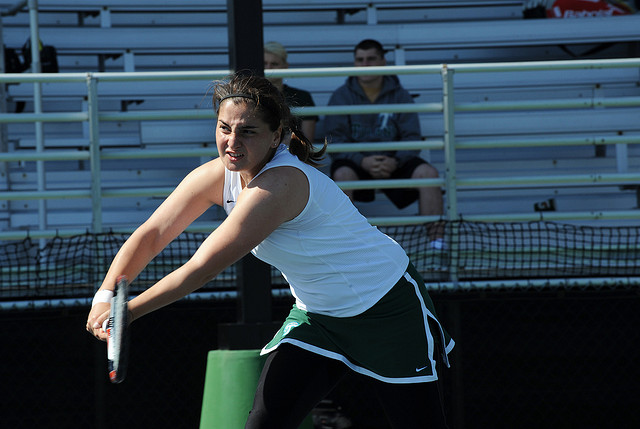Please identify all text content in this image. 7 